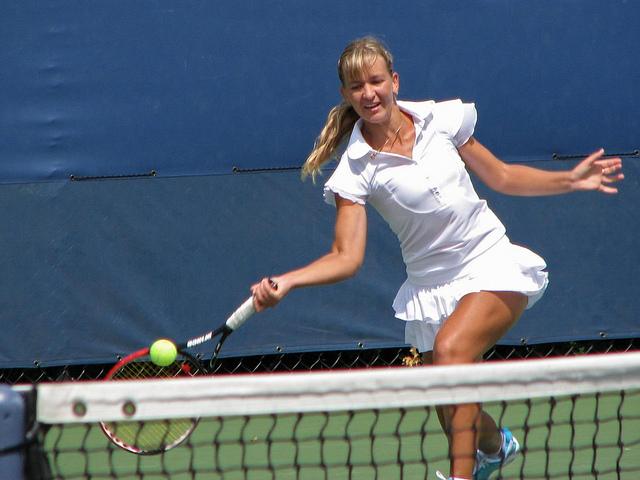What sport is this woman playing?
Short answer required. Tennis. Is the woman smiling?
Keep it brief. Yes. Is she going to hit the ball?
Concise answer only. Yes. 